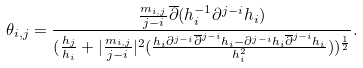<formula> <loc_0><loc_0><loc_500><loc_500>\theta _ { i , j } = \frac { \frac { m _ { i , j } } { j - i } \overline { \partial } ( h _ { i } ^ { - 1 } \partial ^ { j - i } h _ { i } ) } { ( \frac { h _ { j } } { h _ { i } } + | \frac { m _ { i , j } } { j - i } | ^ { 2 } ( \frac { h _ { i } \partial ^ { j - i } \overline { \partial } ^ { j - i } h _ { i } - \partial ^ { j - i } h _ { i } \overline { \partial } ^ { j - i } h _ { i } } { h ^ { 2 } _ { i } } ) ) ^ { \frac { 1 } { 2 } } } .</formula> 